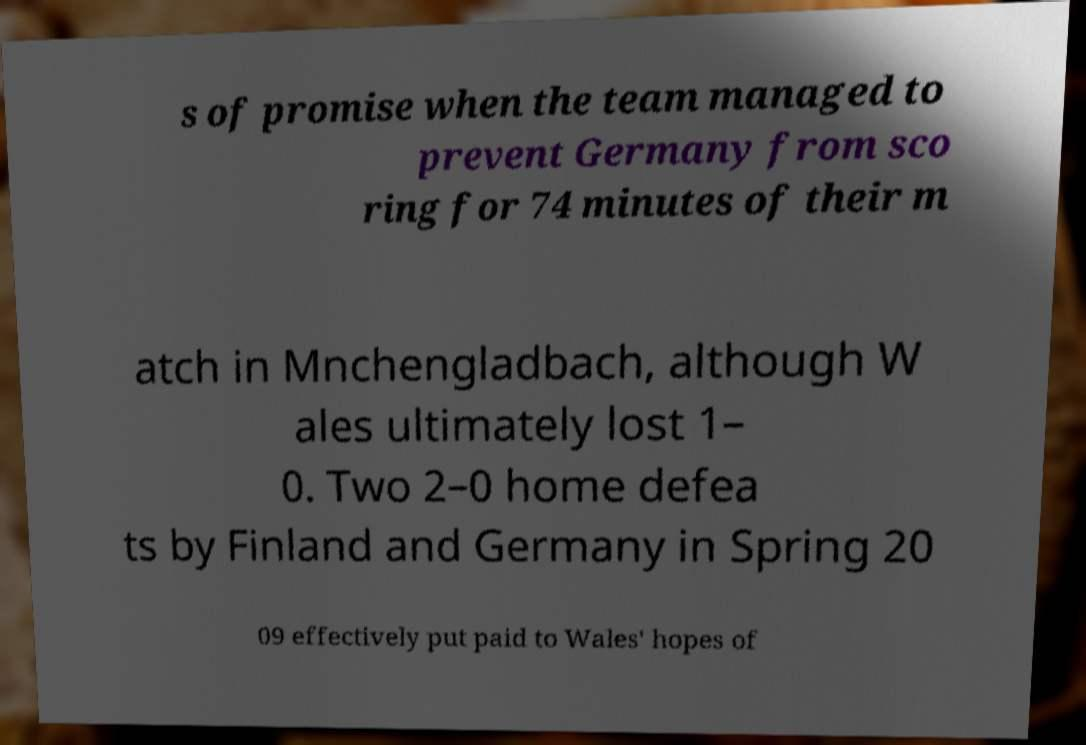Could you assist in decoding the text presented in this image and type it out clearly? s of promise when the team managed to prevent Germany from sco ring for 74 minutes of their m atch in Mnchengladbach, although W ales ultimately lost 1– 0. Two 2–0 home defea ts by Finland and Germany in Spring 20 09 effectively put paid to Wales' hopes of 